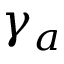<formula> <loc_0><loc_0><loc_500><loc_500>\gamma _ { a }</formula> 